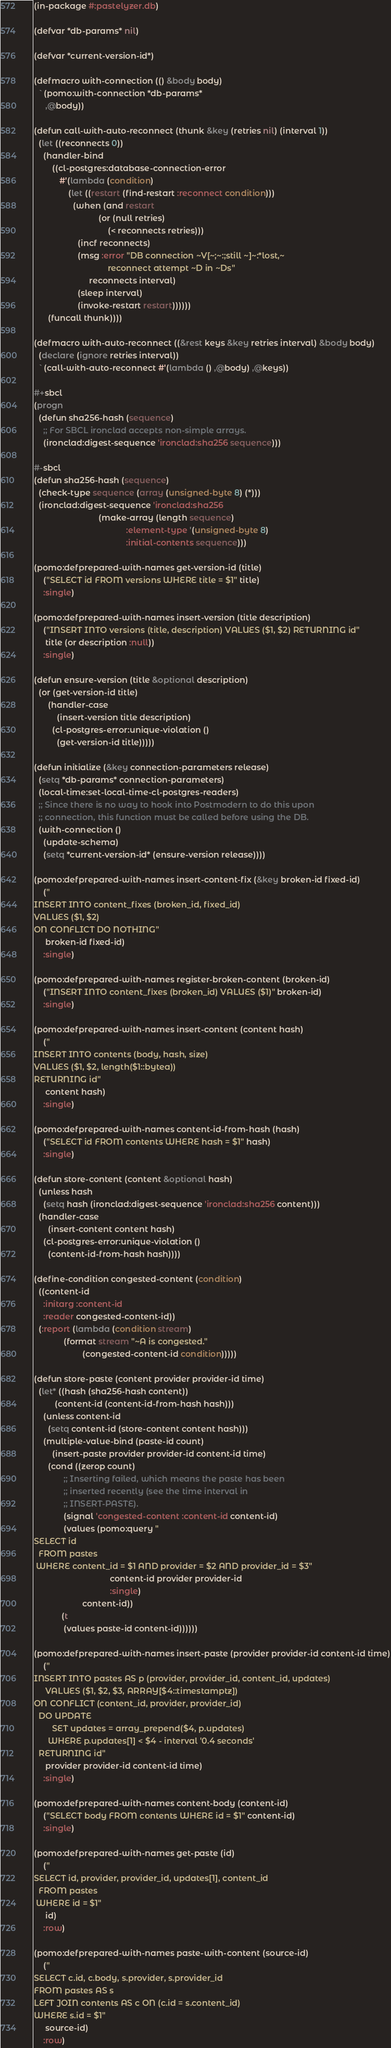Convert code to text. <code><loc_0><loc_0><loc_500><loc_500><_Lisp_>(in-package #:pastelyzer.db)

(defvar *db-params* nil)

(defvar *current-version-id*)

(defmacro with-connection (() &body body)
  `(pomo:with-connection *db-params*
     ,@body))

(defun call-with-auto-reconnect (thunk &key (retries nil) (interval 1))
  (let ((reconnects 0))
    (handler-bind
        ((cl-postgres:database-connection-error
           #'(lambda (condition)
               (let ((restart (find-restart :reconnect condition)))
                 (when (and restart
                            (or (null retries)
                                (< reconnects retries)))
                   (incf reconnects)
                   (msg :error "DB connection ~V[~;~:;still ~]~:*lost,~
                                reconnect attempt ~D in ~Ds"
                        reconnects interval)
                   (sleep interval)
                   (invoke-restart restart))))))
      (funcall thunk))))

(defmacro with-auto-reconnect ((&rest keys &key retries interval) &body body)
  (declare (ignore retries interval))
  `(call-with-auto-reconnect #'(lambda () ,@body) ,@keys))

#+sbcl
(progn
  (defun sha256-hash (sequence)
    ;; For SBCL ironclad accepts non-simple arrays.
    (ironclad:digest-sequence 'ironclad:sha256 sequence)))

#-sbcl
(defun sha256-hash (sequence)
  (check-type sequence (array (unsigned-byte 8) (*)))
  (ironclad:digest-sequence 'ironclad:sha256
                            (make-array (length sequence)
                                        :element-type '(unsigned-byte 8)
                                        :initial-contents sequence)))

(pomo:defprepared-with-names get-version-id (title)
    ("SELECT id FROM versions WHERE title = $1" title)
    :single)

(pomo:defprepared-with-names insert-version (title description)
    ("INSERT INTO versions (title, description) VALUES ($1, $2) RETURNING id"
     title (or description :null))
    :single)

(defun ensure-version (title &optional description)
  (or (get-version-id title)
      (handler-case
          (insert-version title description)
        (cl-postgres-error:unique-violation ()
          (get-version-id title)))))

(defun initialize (&key connection-parameters release)
  (setq *db-params* connection-parameters)
  (local-time:set-local-time-cl-postgres-readers)
  ;; Since there is no way to hook into Postmodern to do this upon
  ;; connection, this function must be called before using the DB.
  (with-connection ()
    (update-schema)
    (setq *current-version-id* (ensure-version release))))

(pomo:defprepared-with-names insert-content-fix (&key broken-id fixed-id)
    ("
INSERT INTO content_fixes (broken_id, fixed_id)
VALUES ($1, $2)
ON CONFLICT DO NOTHING"
     broken-id fixed-id)
    :single)

(pomo:defprepared-with-names register-broken-content (broken-id)
    ("INSERT INTO content_fixes (broken_id) VALUES ($1)" broken-id)
    :single)

(pomo:defprepared-with-names insert-content (content hash)
    ("
INSERT INTO contents (body, hash, size)
VALUES ($1, $2, length($1::bytea))
RETURNING id"
     content hash)
    :single)

(pomo:defprepared-with-names content-id-from-hash (hash)
    ("SELECT id FROM contents WHERE hash = $1" hash)
    :single)

(defun store-content (content &optional hash)
  (unless hash
    (setq hash (ironclad:digest-sequence 'ironclad:sha256 content)))
  (handler-case
      (insert-content content hash)
    (cl-postgres-error:unique-violation ()
      (content-id-from-hash hash))))

(define-condition congested-content (condition)
  ((content-id
    :initarg :content-id
    :reader congested-content-id))
  (:report (lambda (condition stream)
             (format stream "~A is congested."
                     (congested-content-id condition)))))

(defun store-paste (content provider provider-id time)
  (let* ((hash (sha256-hash content))
         (content-id (content-id-from-hash hash)))
    (unless content-id
      (setq content-id (store-content content hash)))
    (multiple-value-bind (paste-id count)
        (insert-paste provider provider-id content-id time)
      (cond ((zerop count)
             ;; Inserting failed, which means the paste has been
             ;; inserted recently (see the time interval in
             ;; INSERT-PASTE).
             (signal 'congested-content :content-id content-id)
             (values (pomo:query "
SELECT id
  FROM pastes
 WHERE content_id = $1 AND provider = $2 AND provider_id = $3"
                                 content-id provider provider-id
                                 :single)
                     content-id))
            (t
             (values paste-id content-id))))))

(pomo:defprepared-with-names insert-paste (provider provider-id content-id time)
    ("
INSERT INTO pastes AS p (provider, provider_id, content_id, updates)
     VALUES ($1, $2, $3, ARRAY[$4::timestamptz])
ON CONFLICT (content_id, provider, provider_id)
  DO UPDATE
        SET updates = array_prepend($4, p.updates)
      WHERE p.updates[1] < $4 - interval '0.4 seconds'
  RETURNING id"
     provider provider-id content-id time)
    :single)

(pomo:defprepared-with-names content-body (content-id)
    ("SELECT body FROM contents WHERE id = $1" content-id)
    :single)

(pomo:defprepared-with-names get-paste (id)
    ("
SELECT id, provider, provider_id, updates[1], content_id
  FROM pastes
 WHERE id = $1"
     id)
    :row)

(pomo:defprepared-with-names paste-with-content (source-id)
    ("
SELECT c.id, c.body, s.provider, s.provider_id
FROM pastes AS s
LEFT JOIN contents AS c ON (c.id = s.content_id)
WHERE s.id = $1"
     source-id)
    :row)
</code> 